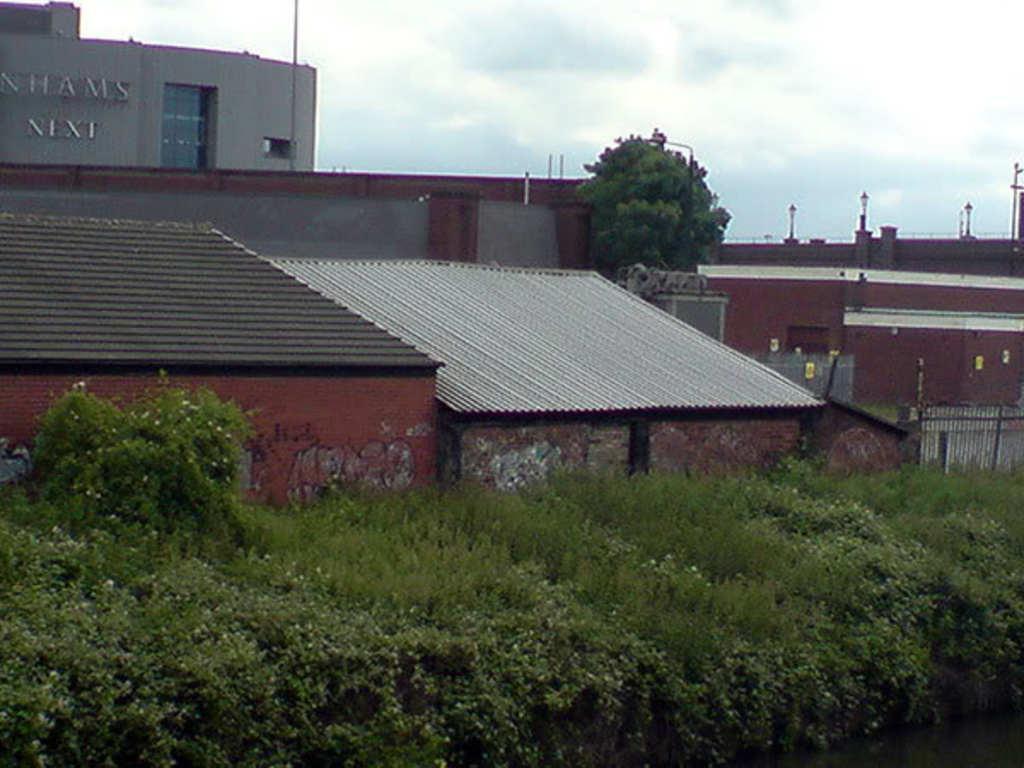Can you describe this image briefly? In this image there is the sky towards the top of the image, there are clouds in the sky, there is a building towards the left of the image, there is text on the building, there is a wall towards the right of the image, there are poles, there are lights, there is a wall towards the left of the image, there is a roof, there is a fence towards the right of the image, there are plants towards the bottom of the image. 